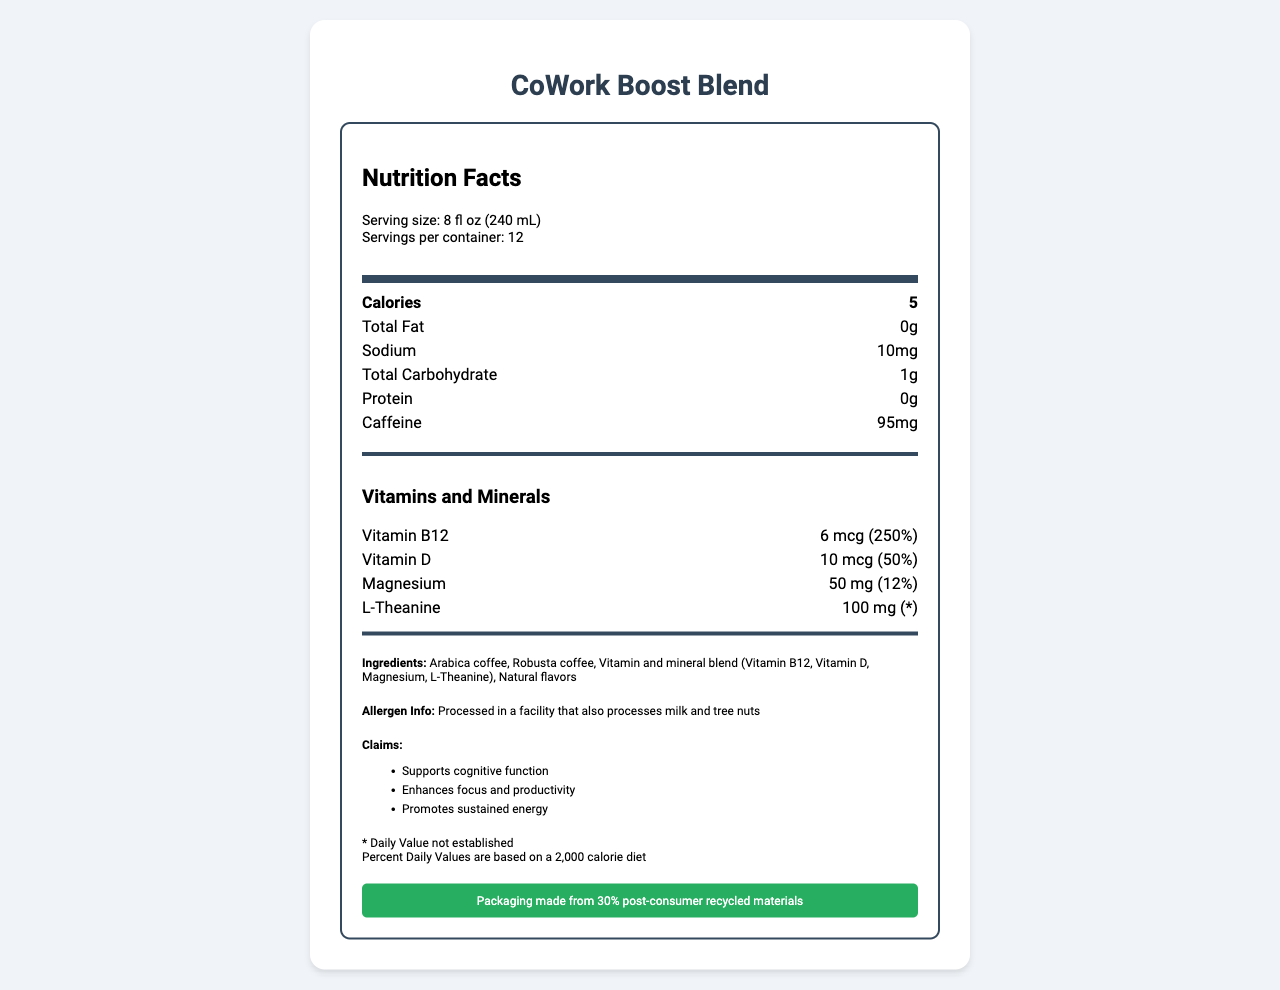what is the serving size for CoWork Boost Blend? The serving size is listed in the document under the heading "Serving size".
Answer: 8 fl oz (240 mL) how many servings are there per container? The number of servings per container is given under the heading "Servings per container".
Answer: 12 how many calories are in one serving? The calorie content per serving is listed under the main "Calories" section.
Answer: 5 what is the amount of caffeine per serving? The amount of caffeine per serving is specified in the nutrients section of the document.
Answer: 95 mg which vitamins are included in CoWork Boost Blend? The vitamins part lists Vitamin B12 and Vitamin D along with their amounts and daily values.
Answer: Vitamin B12, Vitamin D what is the percentage of Daily Value for Vitamin D? The daily value for Vitamin D is mentioned next to the amount in the vitamins section.
Answer: 50% what ingredients does CoWork Boost Blend contain? The ingredients are listed under the "Ingredients" section.
Answer: Arabica coffee, Robusta coffee, Vitamin and mineral blend (Vitamin B12, Vitamin D, Magnesium, L-Theanine), Natural flavors where is CoWork Boost Blend manufactured? The manufacturer information is provided at the bottom of the document under the preparation and storage instructions.
Answer: InnovateCafe Labs, San Francisco, CA 94107 what is the daily value for L-Theanine? The daily value for L-Theanine is marked with an asterisk, indicating that it is not established.
Answer: * how should CoWork Boost Blend be stored? The storage instructions mention that the product should be kept in a cool, dry place.
Answer: In a cool, dry place which of the claims is NOT true about CoWork Boost Blend? A) Supports cognitive function B) Enhances focus and productivity C) Contains milk and tree nuts The document claims that the blend supports cognitive function, enhances focus and productivity, but does not claim to contain milk and tree nuts; rather, it mentions being processed in a facility that processes such allergens.
Answer: C what are the potential allergens in CoWork Boost Blend? A) Gluten and soy B) Milk and tree nuts C) Peanuts and shellfish The document's allergen information section states that the product is processed in a facility that also processes milk and tree nuts.
Answer: B does CoWork Boost Blend support sustainable practices? The sustainability claim indicates that the packaging is made from 30% post-consumer recycled materials.
Answer: Yes describe the primary focus of CoWork Boost Blend? The blend contains specific ingredients and claims to support cognitive function, focus, and sustained energy, making it suitable for productivity-focused individuals.
Answer: CoWork Boost Blend is a specialty coffee designed to enhance productivity and cognitive function, containing added vitamins and minerals tailored for individuals in coworking environments. what's the price of CoWork Boost Blend? The document does not provide any information about the price.
Answer: Cannot be determined is L-Theanine included in the vitamin and mineral blend? L-Theanine is listed as part of the vitamin and mineral blend in the ingredients section.
Answer: Yes 